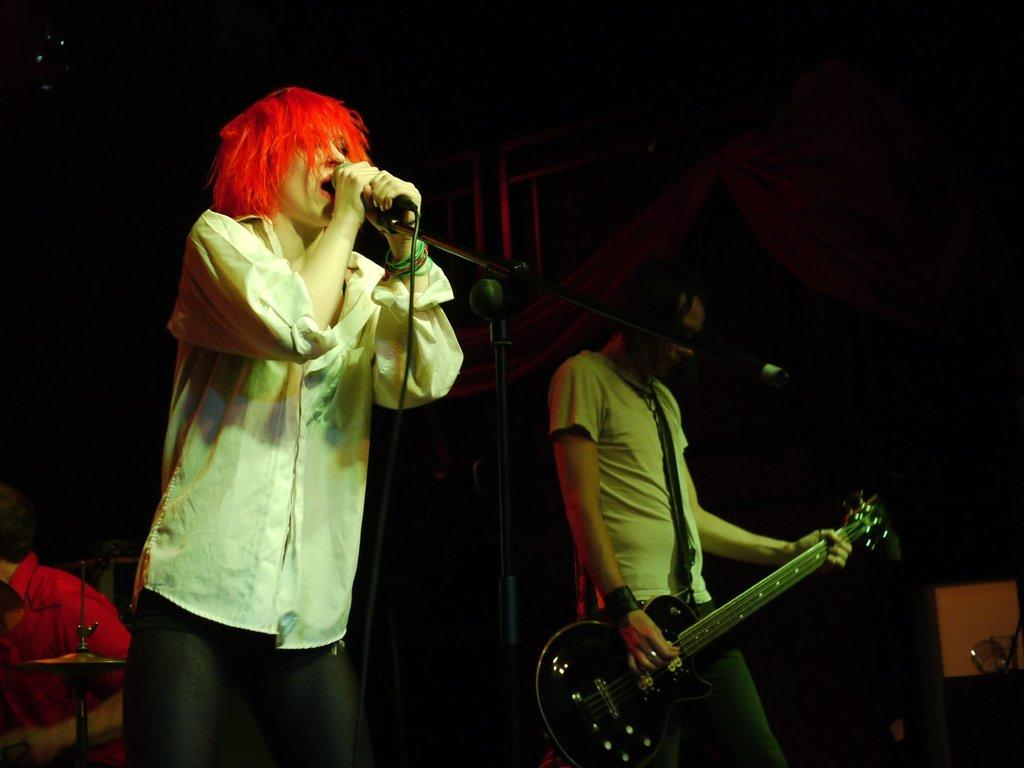What is the person in the image doing? The person is singing a song and holding a microphone. What is the person wearing? The person is wearing a white shirt. Are there any other people in the image? Yes, there is another person in the image. What is the second person doing? The second person is playing a guitar. What type of cow is present in the image? There is no cow present in the image. What kind of jewel is the person wearing on their head? The person in the image is not wearing any jewel on their head. 